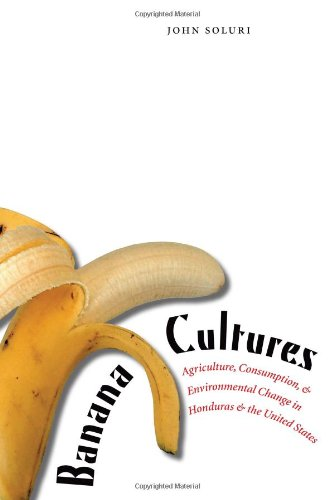Is this a historical book? Yes, this is a historical book. It deeply delves into the historical contexts that shaped banana agriculture in Honduras and the U.S., reflecting on broader environmental impacts. 